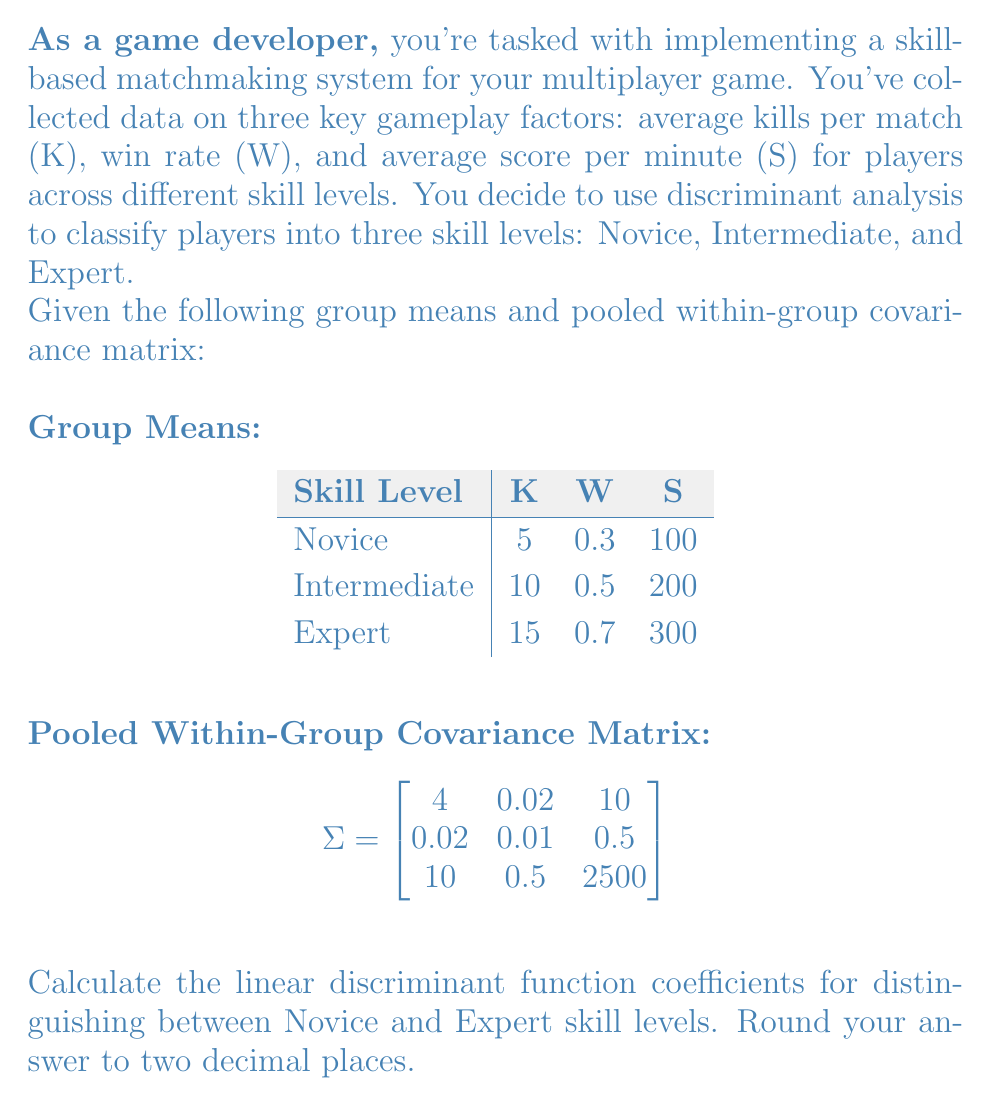Solve this math problem. To calculate the linear discriminant function coefficients, we'll follow these steps:

1) The linear discriminant function between two groups is given by:

   $f(x) = (\mu_2 - \mu_1)^T \Sigma^{-1} x$

   where $\mu_2$ and $\mu_1$ are the mean vectors of the two groups, and $\Sigma^{-1}$ is the inverse of the pooled within-group covariance matrix.

2) First, let's calculate $(\mu_2 - \mu_1)$:

   $\mu_2 - \mu_1 = [15, 0.7, 300] - [5, 0.3, 100] = [10, 0.4, 200]$

3) Next, we need to find $\Sigma^{-1}$. We can use a calculator or computer program to invert the matrix:

   $$\Sigma^{-1} \approx \begin{bmatrix}
   0.2545 & -0.3636 & -0.0010 \\
   -0.3636 & 101.8182 & -0.0182 \\
   -0.0010 & -0.0182 & 0.0004
   \end{bmatrix}$$

4) Now, we calculate $(\mu_2 - \mu_1)^T \Sigma^{-1}$:

   $[10, 0.4, 200] \begin{bmatrix}
   0.2545 & -0.3636 & -0.0010 \\
   -0.3636 & 101.8182 & -0.0182 \\
   -0.0010 & -0.0182 & 0.0004
   \end{bmatrix}$

5) Performing this matrix multiplication:

   $[2.3814, 40.5455, 0.0364]$

6) These are the coefficients of the linear discriminant function. Rounding to two decimal places:

   $[2.38, 40.55, 0.04]$

These coefficients correspond to K, W, and S respectively in the linear discriminant function.
Answer: [2.38, 40.55, 0.04] 